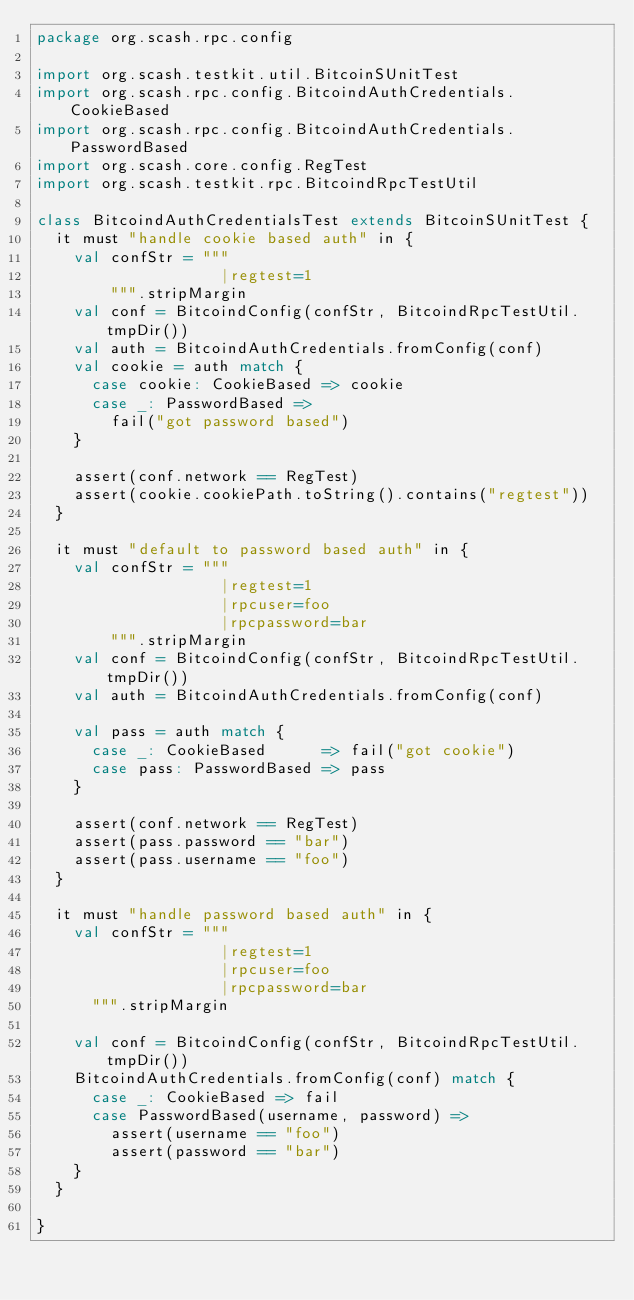<code> <loc_0><loc_0><loc_500><loc_500><_Scala_>package org.scash.rpc.config

import org.scash.testkit.util.BitcoinSUnitTest
import org.scash.rpc.config.BitcoindAuthCredentials.CookieBased
import org.scash.rpc.config.BitcoindAuthCredentials.PasswordBased
import org.scash.core.config.RegTest
import org.scash.testkit.rpc.BitcoindRpcTestUtil

class BitcoindAuthCredentialsTest extends BitcoinSUnitTest {
  it must "handle cookie based auth" in {
    val confStr = """
                    |regtest=1
        """.stripMargin
    val conf = BitcoindConfig(confStr, BitcoindRpcTestUtil.tmpDir())
    val auth = BitcoindAuthCredentials.fromConfig(conf)
    val cookie = auth match {
      case cookie: CookieBased => cookie
      case _: PasswordBased =>
        fail("got password based")
    }

    assert(conf.network == RegTest)
    assert(cookie.cookiePath.toString().contains("regtest"))
  }

  it must "default to password based auth" in {
    val confStr = """
                    |regtest=1
                    |rpcuser=foo
                    |rpcpassword=bar
        """.stripMargin
    val conf = BitcoindConfig(confStr, BitcoindRpcTestUtil.tmpDir())
    val auth = BitcoindAuthCredentials.fromConfig(conf)

    val pass = auth match {
      case _: CookieBased      => fail("got cookie")
      case pass: PasswordBased => pass
    }

    assert(conf.network == RegTest)
    assert(pass.password == "bar")
    assert(pass.username == "foo")
  }

  it must "handle password based auth" in {
    val confStr = """
                    |regtest=1
                    |rpcuser=foo
                    |rpcpassword=bar
      """.stripMargin

    val conf = BitcoindConfig(confStr, BitcoindRpcTestUtil.tmpDir())
    BitcoindAuthCredentials.fromConfig(conf) match {
      case _: CookieBased => fail
      case PasswordBased(username, password) =>
        assert(username == "foo")
        assert(password == "bar")
    }
  }

}
</code> 